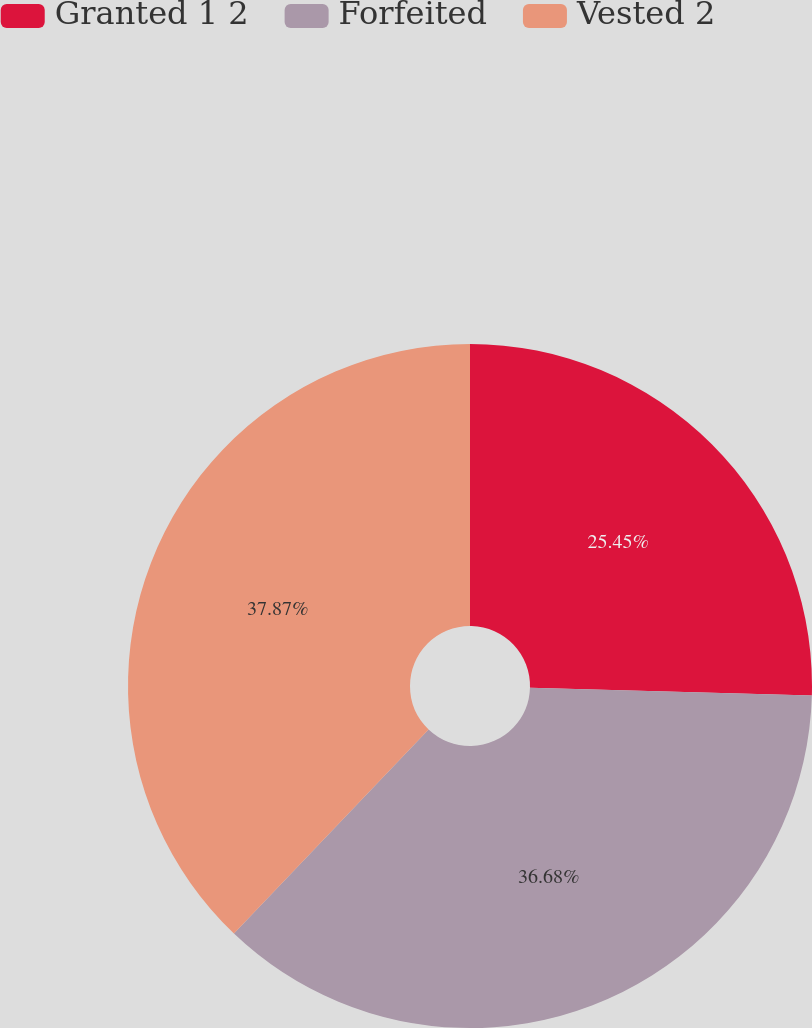Convert chart to OTSL. <chart><loc_0><loc_0><loc_500><loc_500><pie_chart><fcel>Granted 1 2<fcel>Forfeited<fcel>Vested 2<nl><fcel>25.45%<fcel>36.68%<fcel>37.88%<nl></chart> 